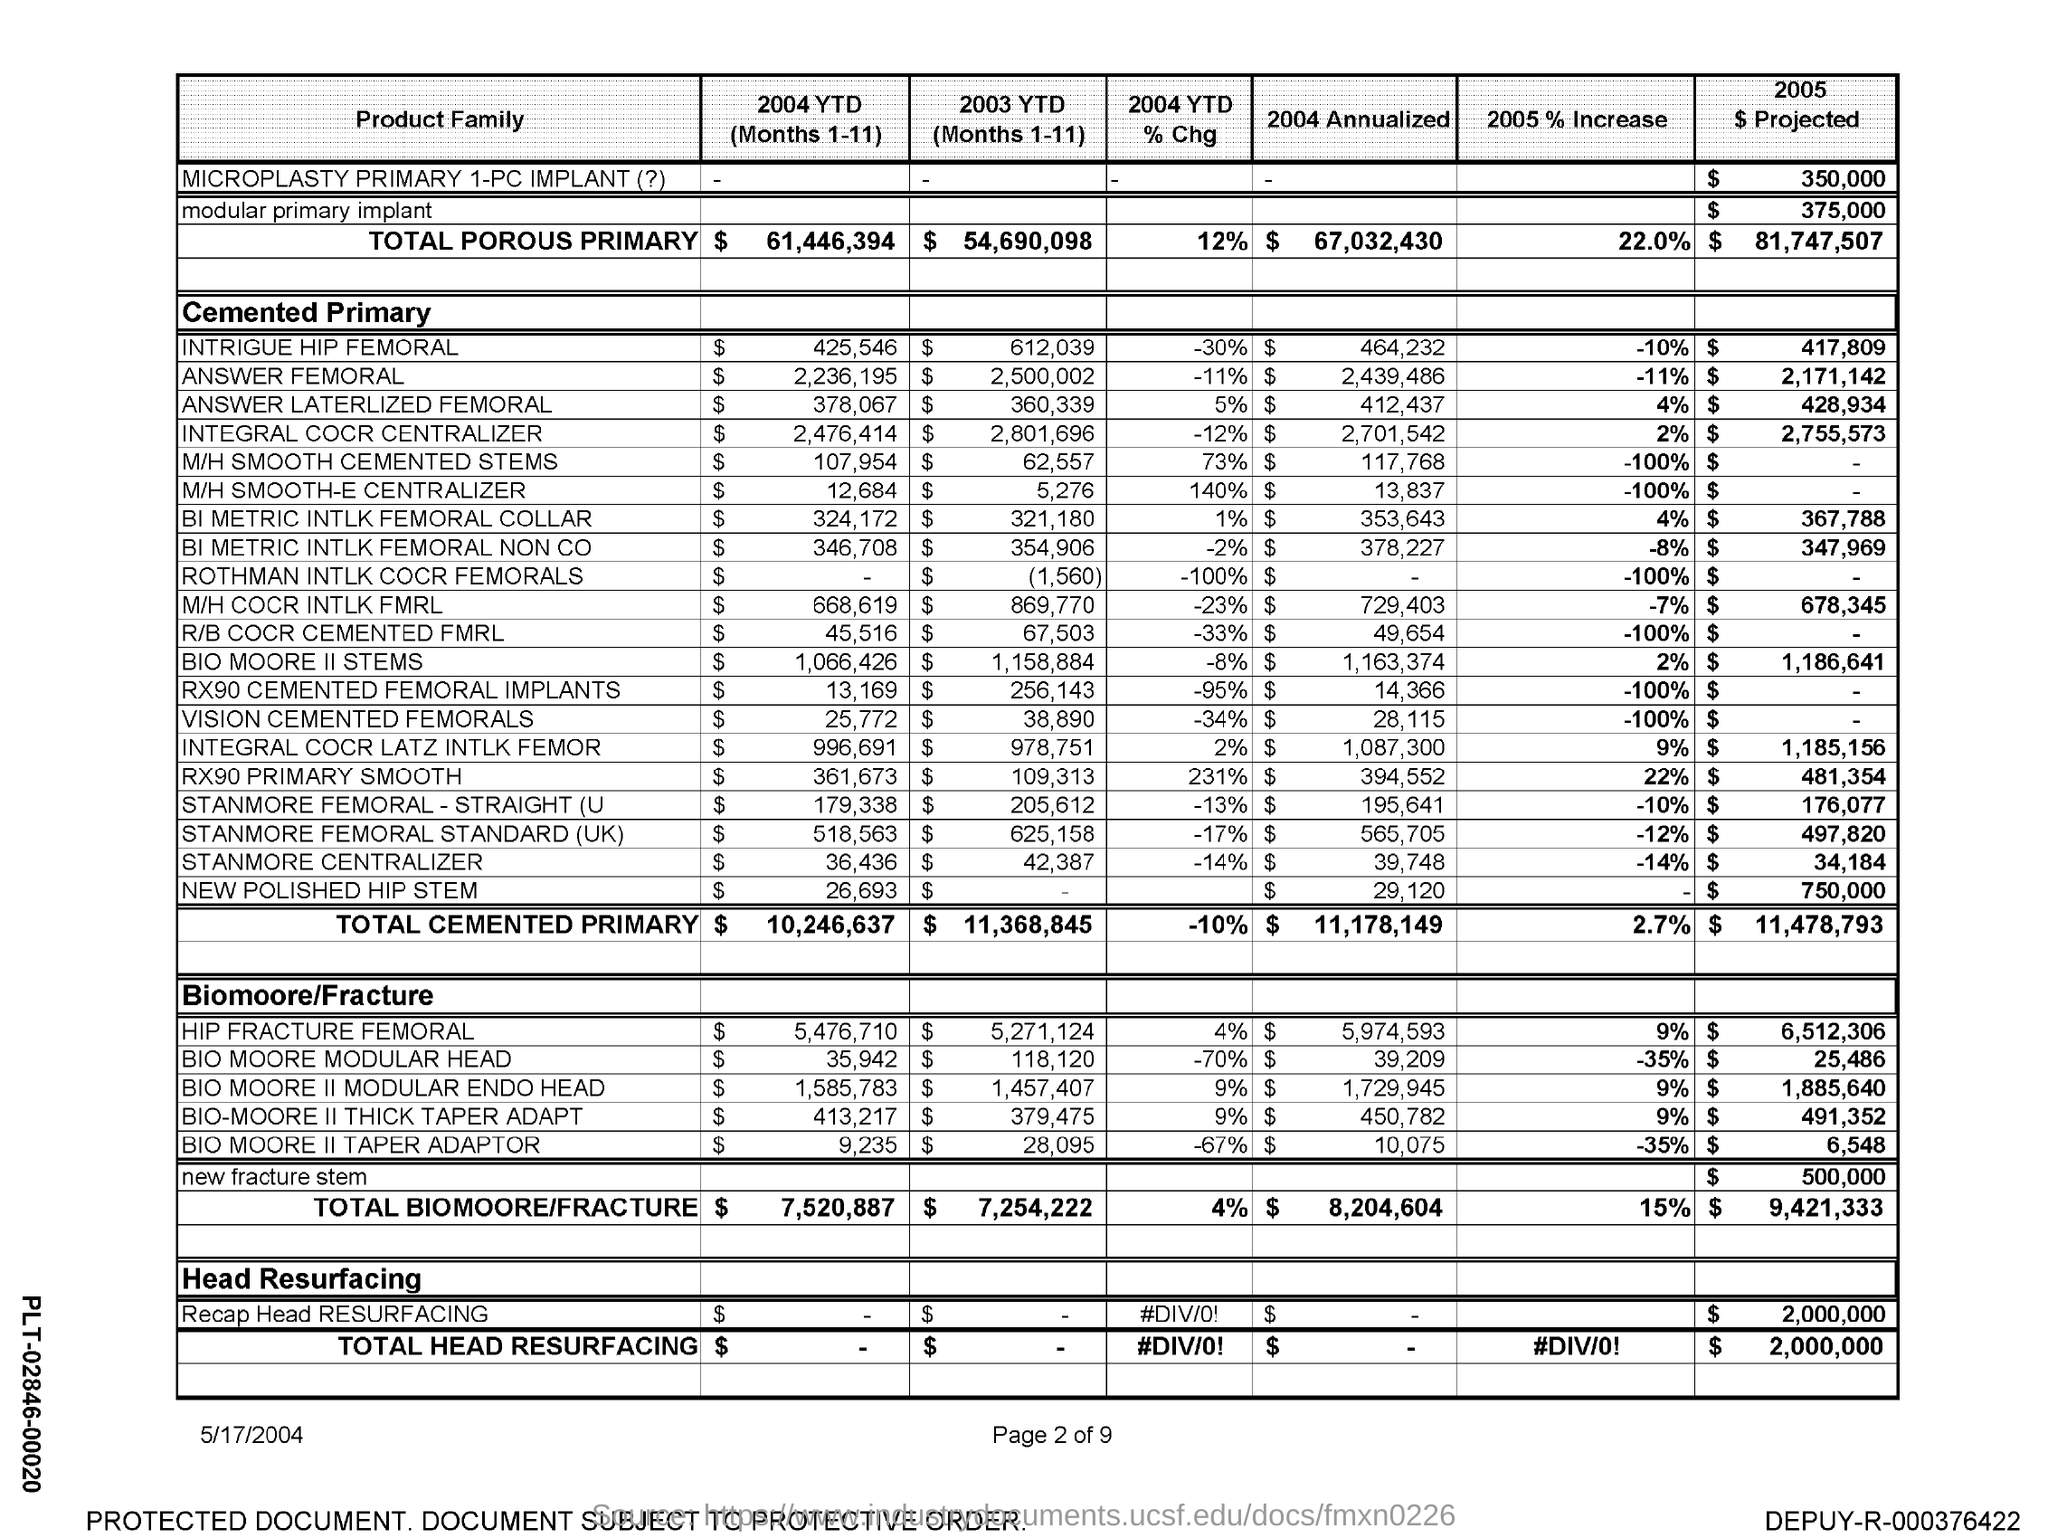What is the total cemented primary for 2004 ytd(months 1-11)
Give a very brief answer. $10,246,637. What is the total cemented primary for 2003 ytd(months 1-11)
Your response must be concise. 11,368,845. What is the total cemented primary for 2004 ytd % chg
Provide a succinct answer. -10%. What is the total cemented primary for 2004  annualized
Your answer should be compact. $ 11,178,149. What is the total cemented primary for 2005% increase
Offer a terse response. 2.7%. What is the total cemented primary for 2005 $ projected
Your answer should be very brief. 11,478,793. 